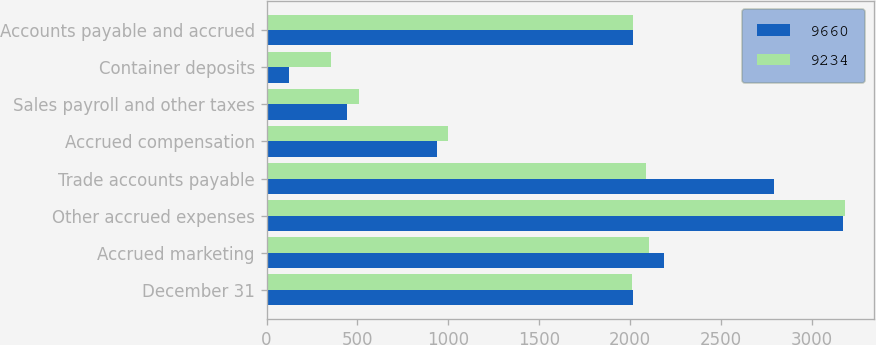Convert chart to OTSL. <chart><loc_0><loc_0><loc_500><loc_500><stacked_bar_chart><ecel><fcel>December 31<fcel>Accrued marketing<fcel>Other accrued expenses<fcel>Trade accounts payable<fcel>Accrued compensation<fcel>Sales payroll and other taxes<fcel>Container deposits<fcel>Accounts payable and accrued<nl><fcel>9660<fcel>2015<fcel>2186<fcel>3173<fcel>2795<fcel>936<fcel>444<fcel>126<fcel>2014.5<nl><fcel>9234<fcel>2014<fcel>2103<fcel>3182<fcel>2089<fcel>997<fcel>511<fcel>352<fcel>2014.5<nl></chart> 